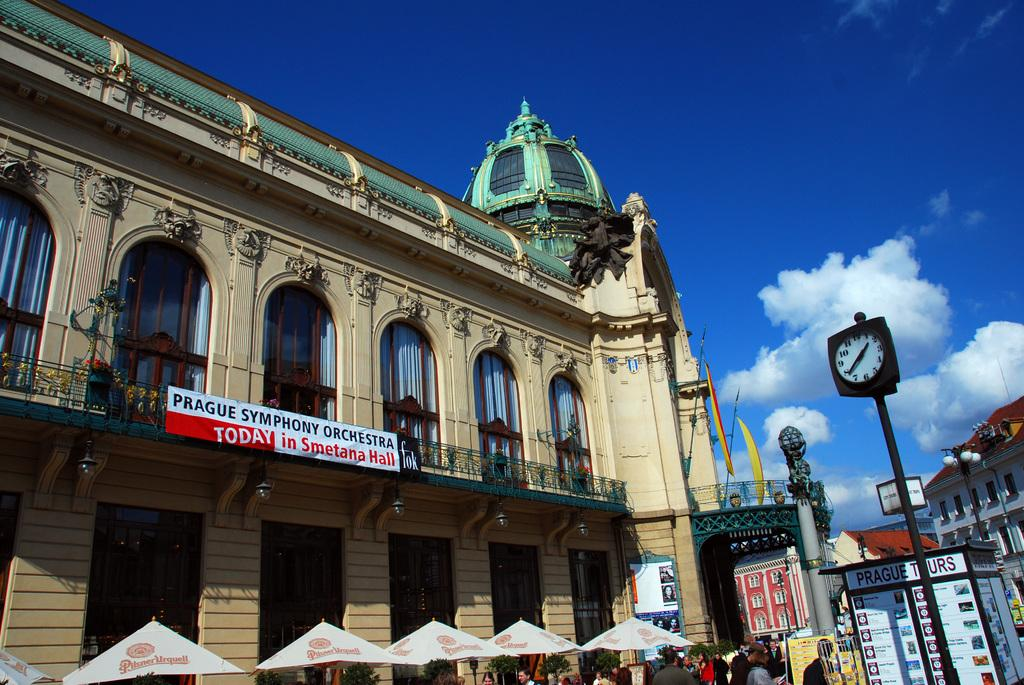How many people are in the image? There is a group of people in the image, but the exact number cannot be determined from the provided facts. What are the people holding in the image? The people in the image are holding umbrellas. What type of structures can be seen in the image? There are buildings in the image. What type of signage is present in the image? There are hoardings in the image. What time-related object is visible in the image? There is a clock in the image. What type of material is present in the image? There are metal rods in the image. What type of boundary is visible in the image? There is no boundary visible in the image. What type of memory is being stored in the image? The image does not depict any memory being stored; it is a static representation of the scene. What type of cooking equipment is visible in the image? There is no cooking equipment visible in the image. 